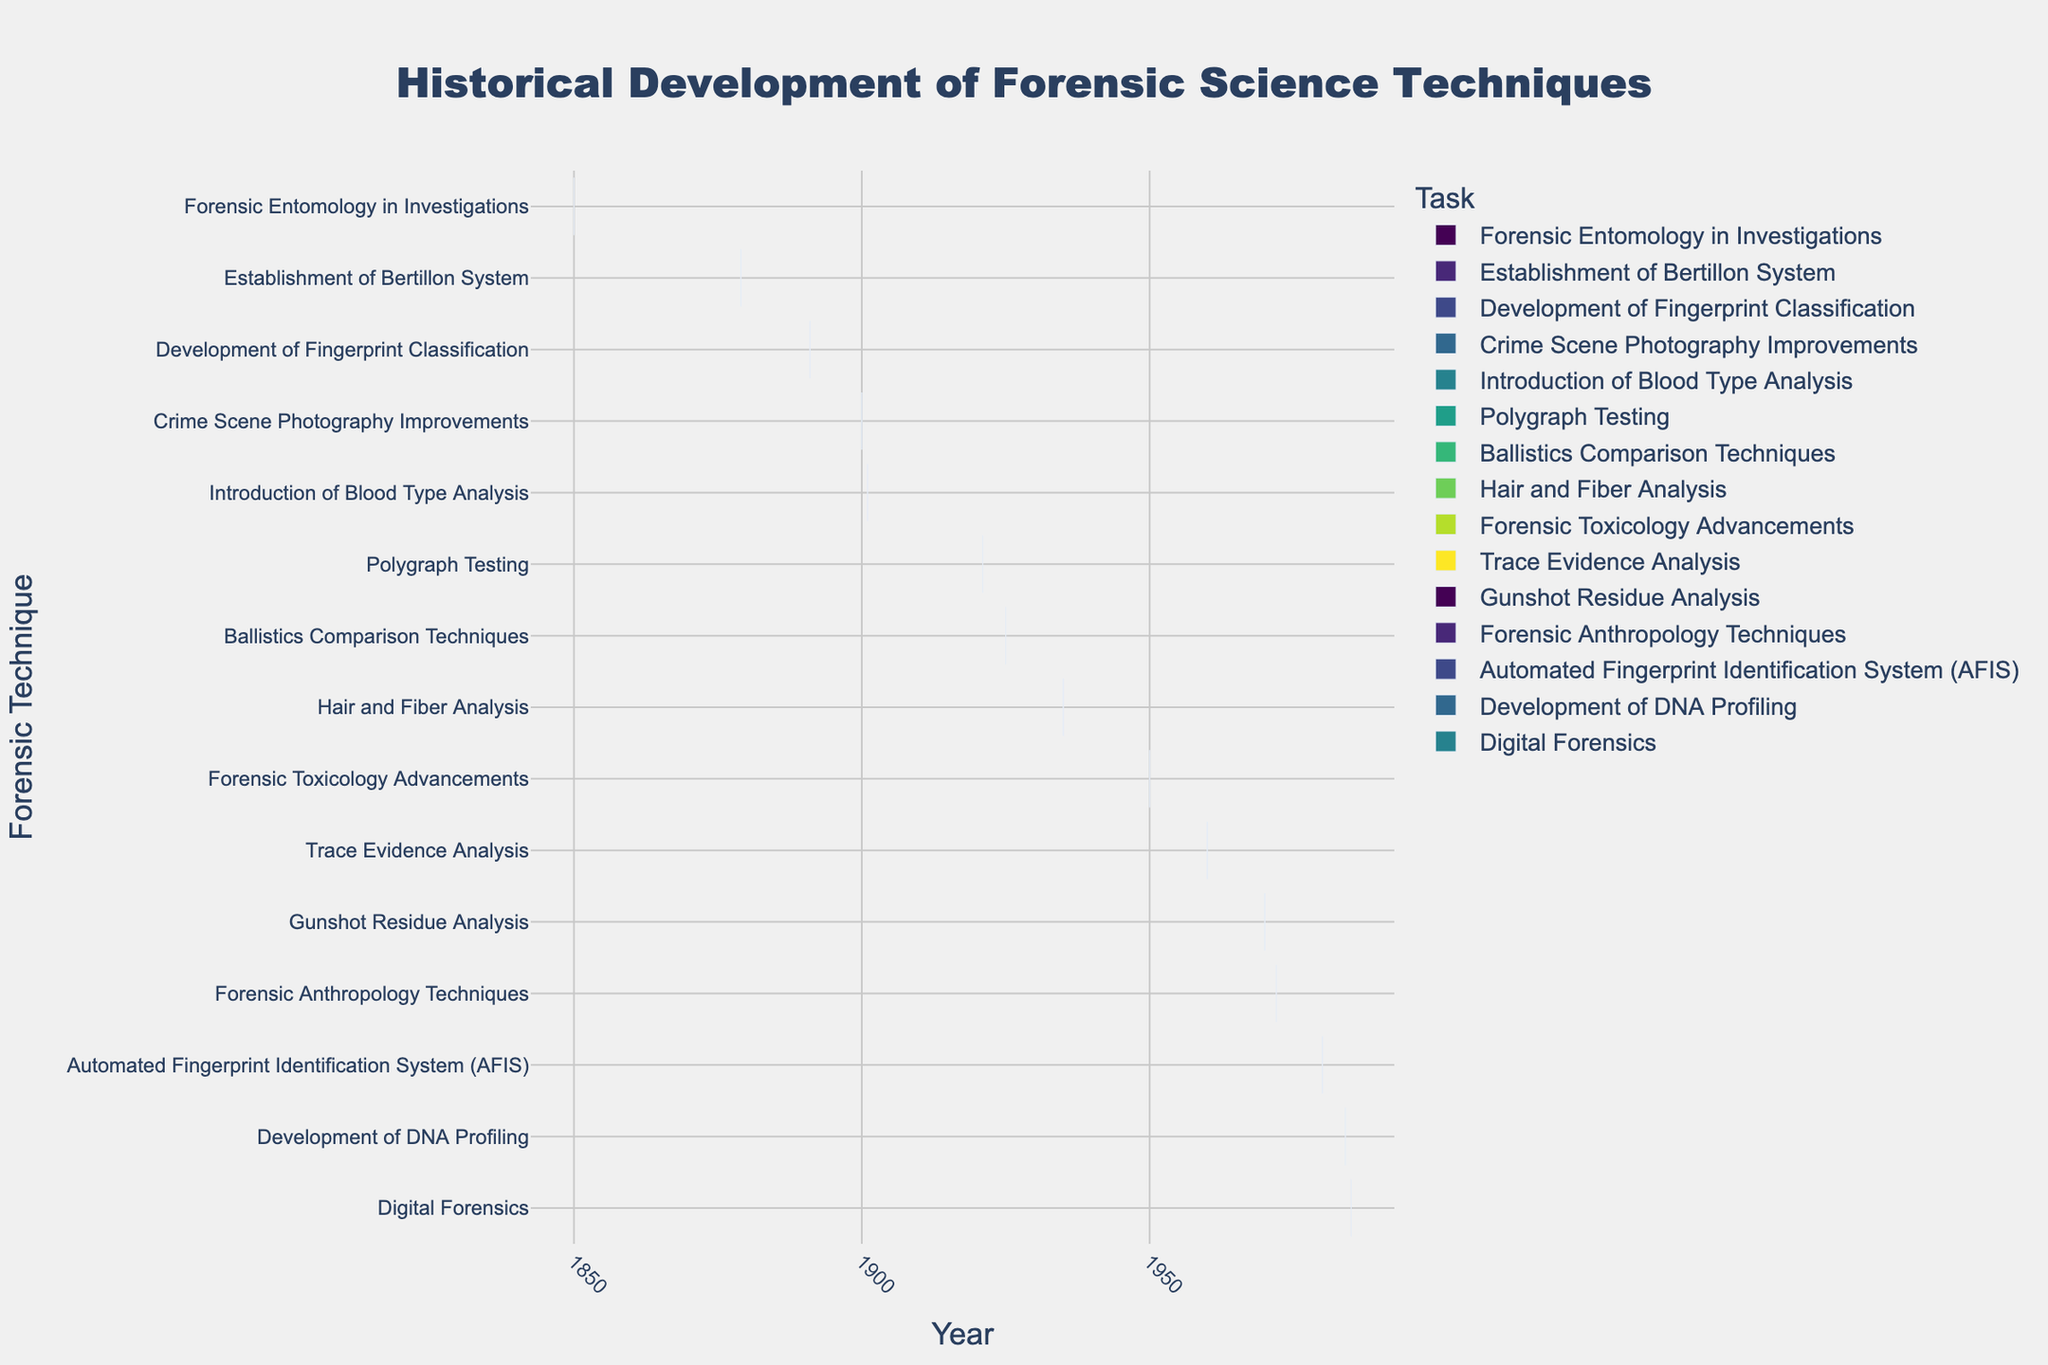What is the title of the figure? The title is usually displayed prominently at the top of the figure. Refer to that area to find the title text.
Answer: Historical Development of Forensic Science Techniques Which forensic technique was introduced earliest according to the chart? Find the task with the earliest start date on the y-axis. The corresponding task label is the answer.
Answer: Forensic Entomology in Investigations What color scheme is used for the tasks in the figure? Look at the color pattern of the bars in the chart. Identify the color scheme based on the visible sequence.
Answer: Viridis How long did the development of DNA Profiling techniques take? Subtract the start year from the end year for the DNA Profiling task (1995 - 1984).
Answer: 11 years Which forensic technique had the longest development period? Compare the duration of each task by subtracting the start year from the end year. Identify the task with the maximum result.
Answer: Digital Forensics How many forensic techniques were developed between 1900 and 1950? Count the number of tasks starting in the range of 1900 to 1950.
Answer: 6 Did the Automated Fingerprint Identification System (AFIS) development overlap with the development of Digital Forensics? Check the start and end years of both AFIS (1980-1999) and Digital Forensics (1985-2005). If the ranges overlap, the answer is yes.
Answer: Yes Which forensic technique had a concurrent duration with Hair and Fiber Analysis? Look for tasks whose time frame overlaps with Hair and Fiber Analysis (1935-1945). Based on start and end years, identify the tasks.
Answer: Crime Scene Photography Improvements, Polygraph Testing What was introduced first: Ballistics Comparison Techniques or Blood Type Analysis? Compare the start years of Ballistics Comparison Techniques (1925) with Blood Type Analysis (1901). The one with the earlier start year is the answer.
Answer: Blood Type Analysis Which forensic technique developed last, according to the chart? Find the task with the latest end year in the figure.
Answer: Digital Forensics 